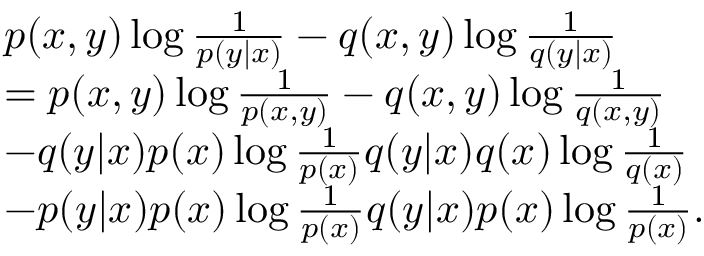Convert formula to latex. <formula><loc_0><loc_0><loc_500><loc_500>\begin{array} { r l } & { p ( x , y ) \log \frac { 1 } { p ( y | x ) } - q ( x , y ) \log \frac { 1 } { q ( y | x ) } } \\ & { = p ( x , y ) \log \frac { 1 } { p ( x , y ) } - q ( x , y ) \log \frac { 1 } { q ( x , y ) } } \\ & { - q ( y | x ) p ( x ) \log \frac { 1 } { p ( x ) } q ( y | x ) q ( x ) \log \frac { 1 } { q ( x ) } } \\ & { - p ( y | x ) p ( x ) \log \frac { 1 } { p ( x ) } q ( y | x ) p ( x ) \log \frac { 1 } { p ( x ) } . } \end{array}</formula> 